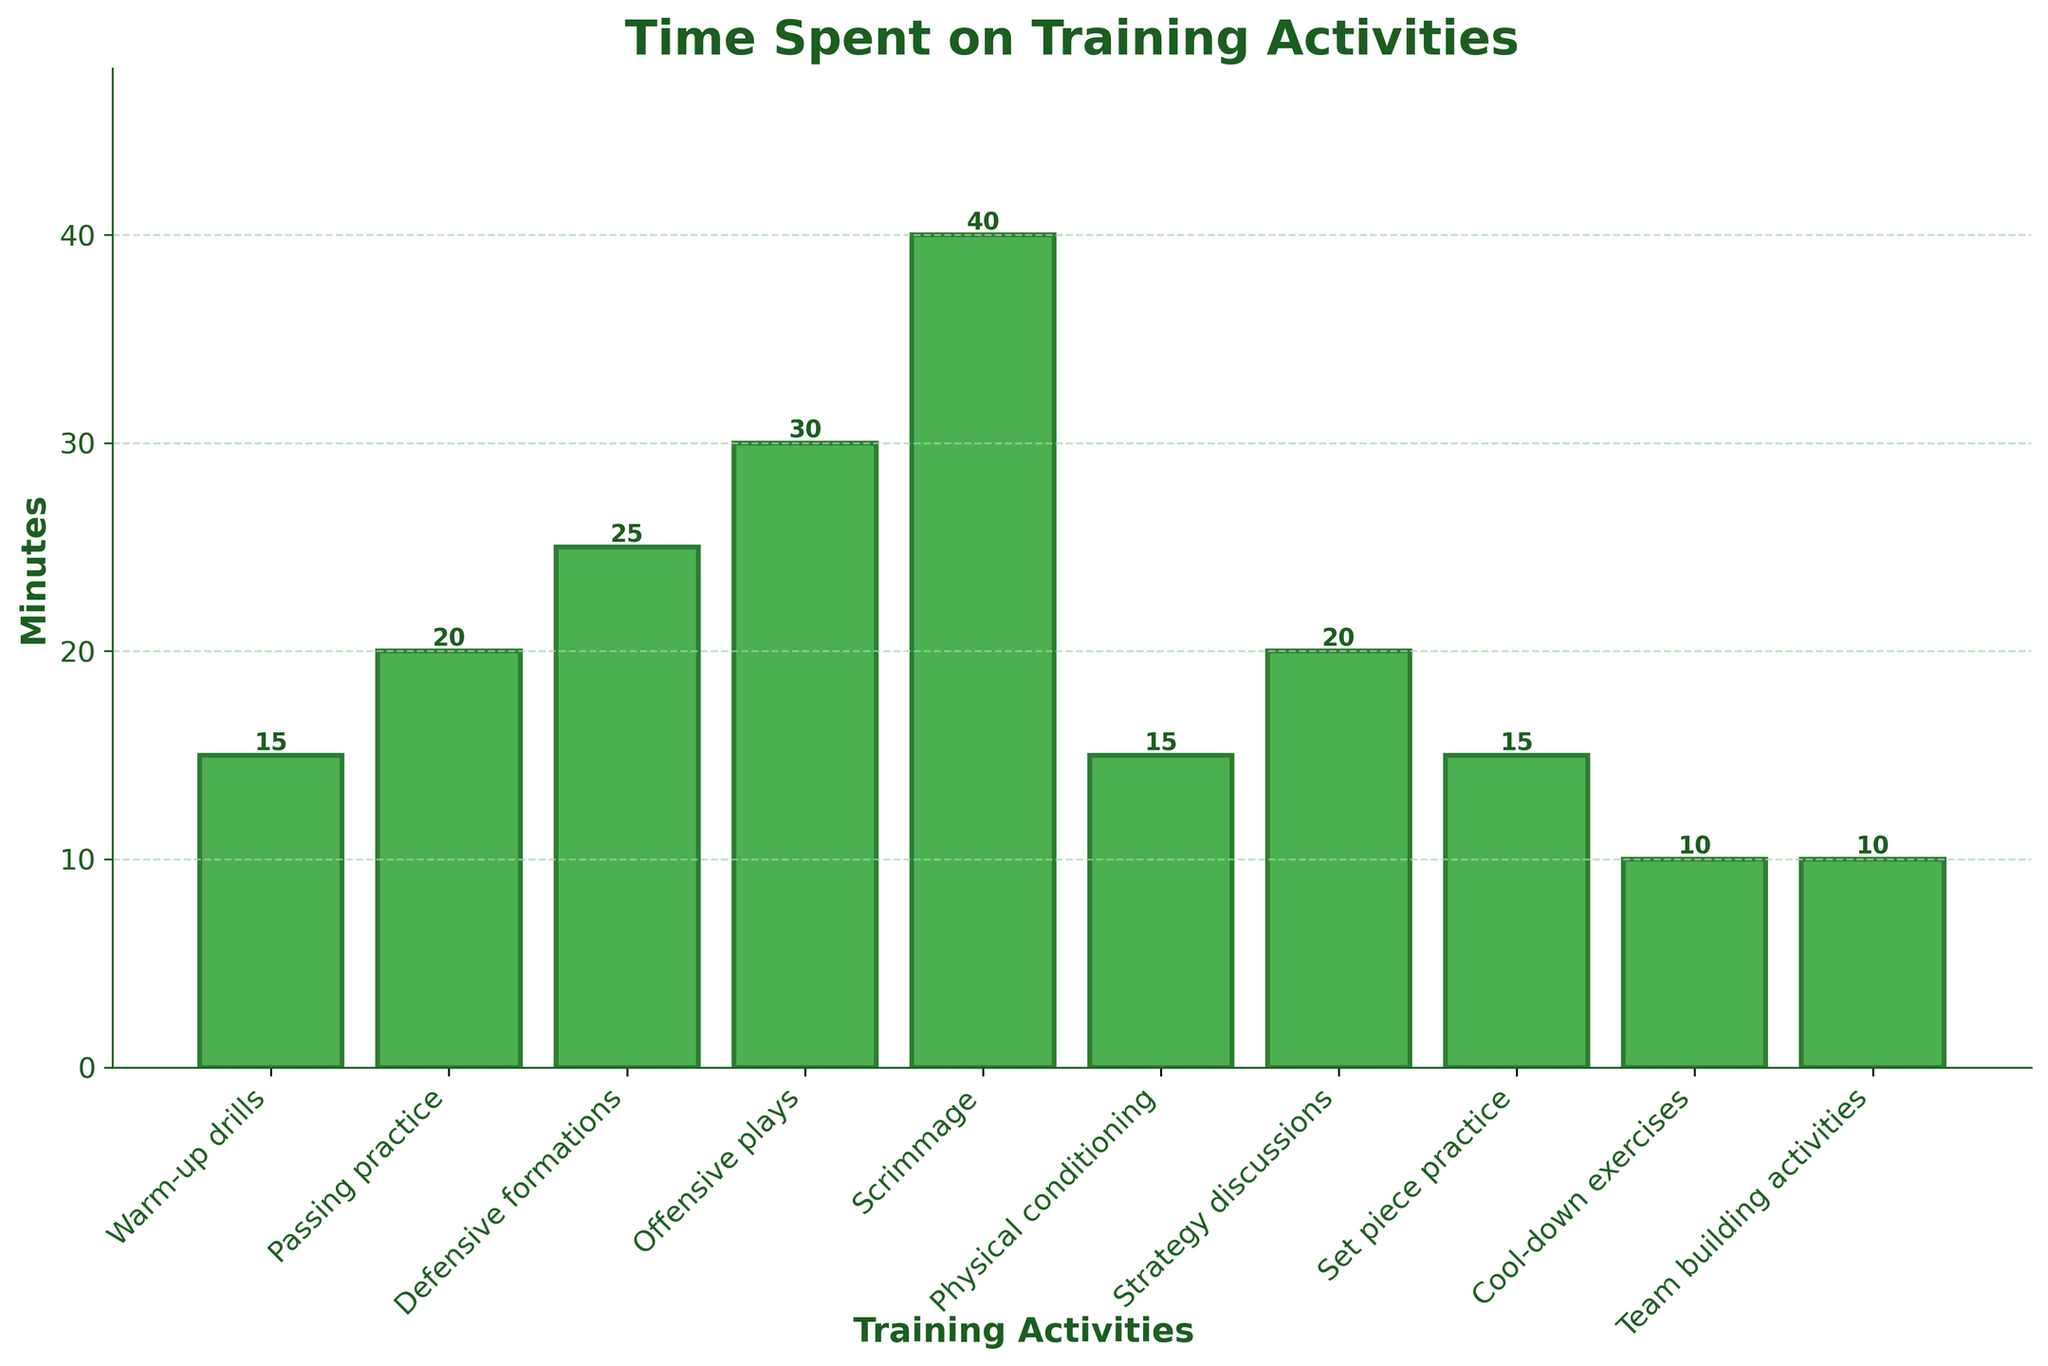Which activity has the longest average time spent? To find this information, look for the tallest bar in the bar chart. The tallest bar represents the activity with the longest average time spent.
Answer: Scrimmage Which two activities take the same amount of time and how much? Examine the heights of the bars to identify any that are equal. The labels under the bars will tell you the activities, and the value on the y-axis will tell you the time.
Answer: Warm-up drills, Physical conditioning, Set piece practice: 15 minutes each How much more time is spent on offensive plays compared to cool-down exercises? Identify the height of the offensive plays bar and the cool-down exercises bar. Subtract the height of the cool-down exercises bar from the height of the offensive plays bar.
Answer: 20 minutes What is the total time spent on training activities that last exactly 20 minutes? Find the bars labeled with activities lasting 20 minutes, then add up these times.
Answer: 40 minutes What is the average time spent on training activities across the session? Add the times of all the activities and divide by the number of activities.
Answer: 200 / 10 = 20 minutes Is the time spent on strategy discussions greater or less than the time spent on passing practice? Compare the heights of the bars for strategy discussions and passing practice.
Answer: Equal Which activities take less than or equal to 15 minutes to complete? Identify and list all the activities where the bars' heights are 15 or below.
Answer: Warm-up drills, Physical conditioning, Set piece practice, Cool-down exercises, Team building activities What is the difference in time spent between the highest and the lowest training activities? Find the maximum bar height and the minimum bar height, then subtract the smallest value from the largest.
Answer: 40 - 10 = 30 minutes If you combined the time spent on defensive formations and offensive plays, how much time would that make up? Add the heights of the bars for defensive formations and offensive plays.
Answer: 55 minutes 